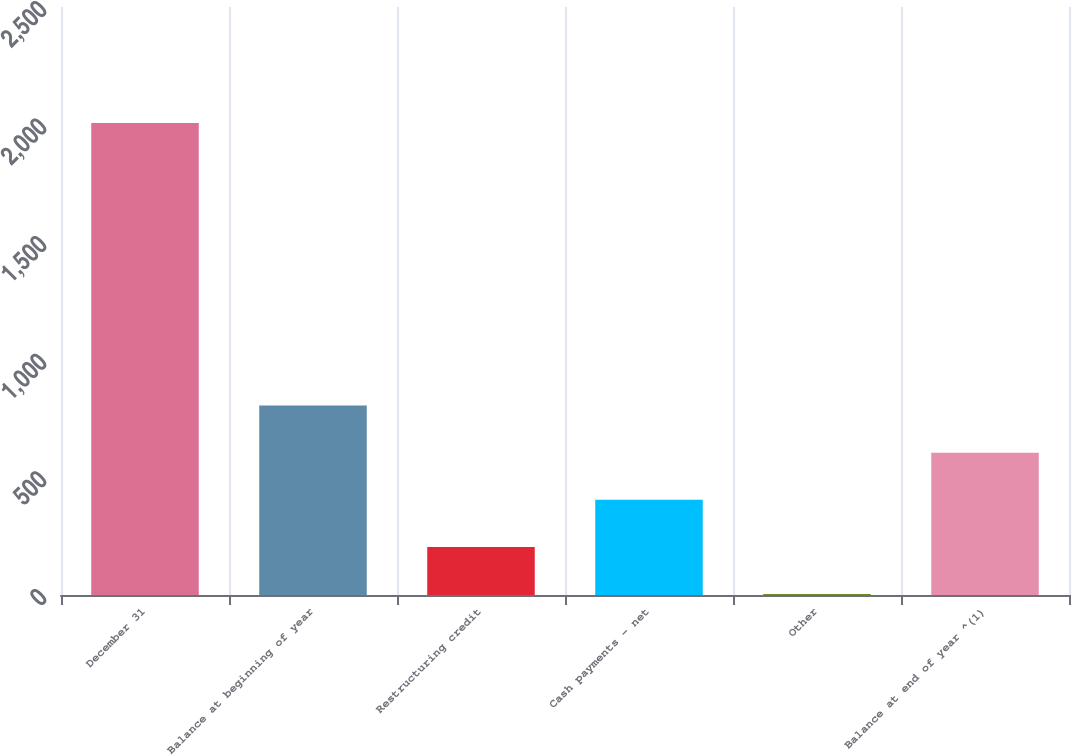Convert chart. <chart><loc_0><loc_0><loc_500><loc_500><bar_chart><fcel>December 31<fcel>Balance at beginning of year<fcel>Restructuring credit<fcel>Cash payments - net<fcel>Other<fcel>Balance at end of year ^(1)<nl><fcel>2007<fcel>805.2<fcel>204.3<fcel>404.6<fcel>4<fcel>604.9<nl></chart> 